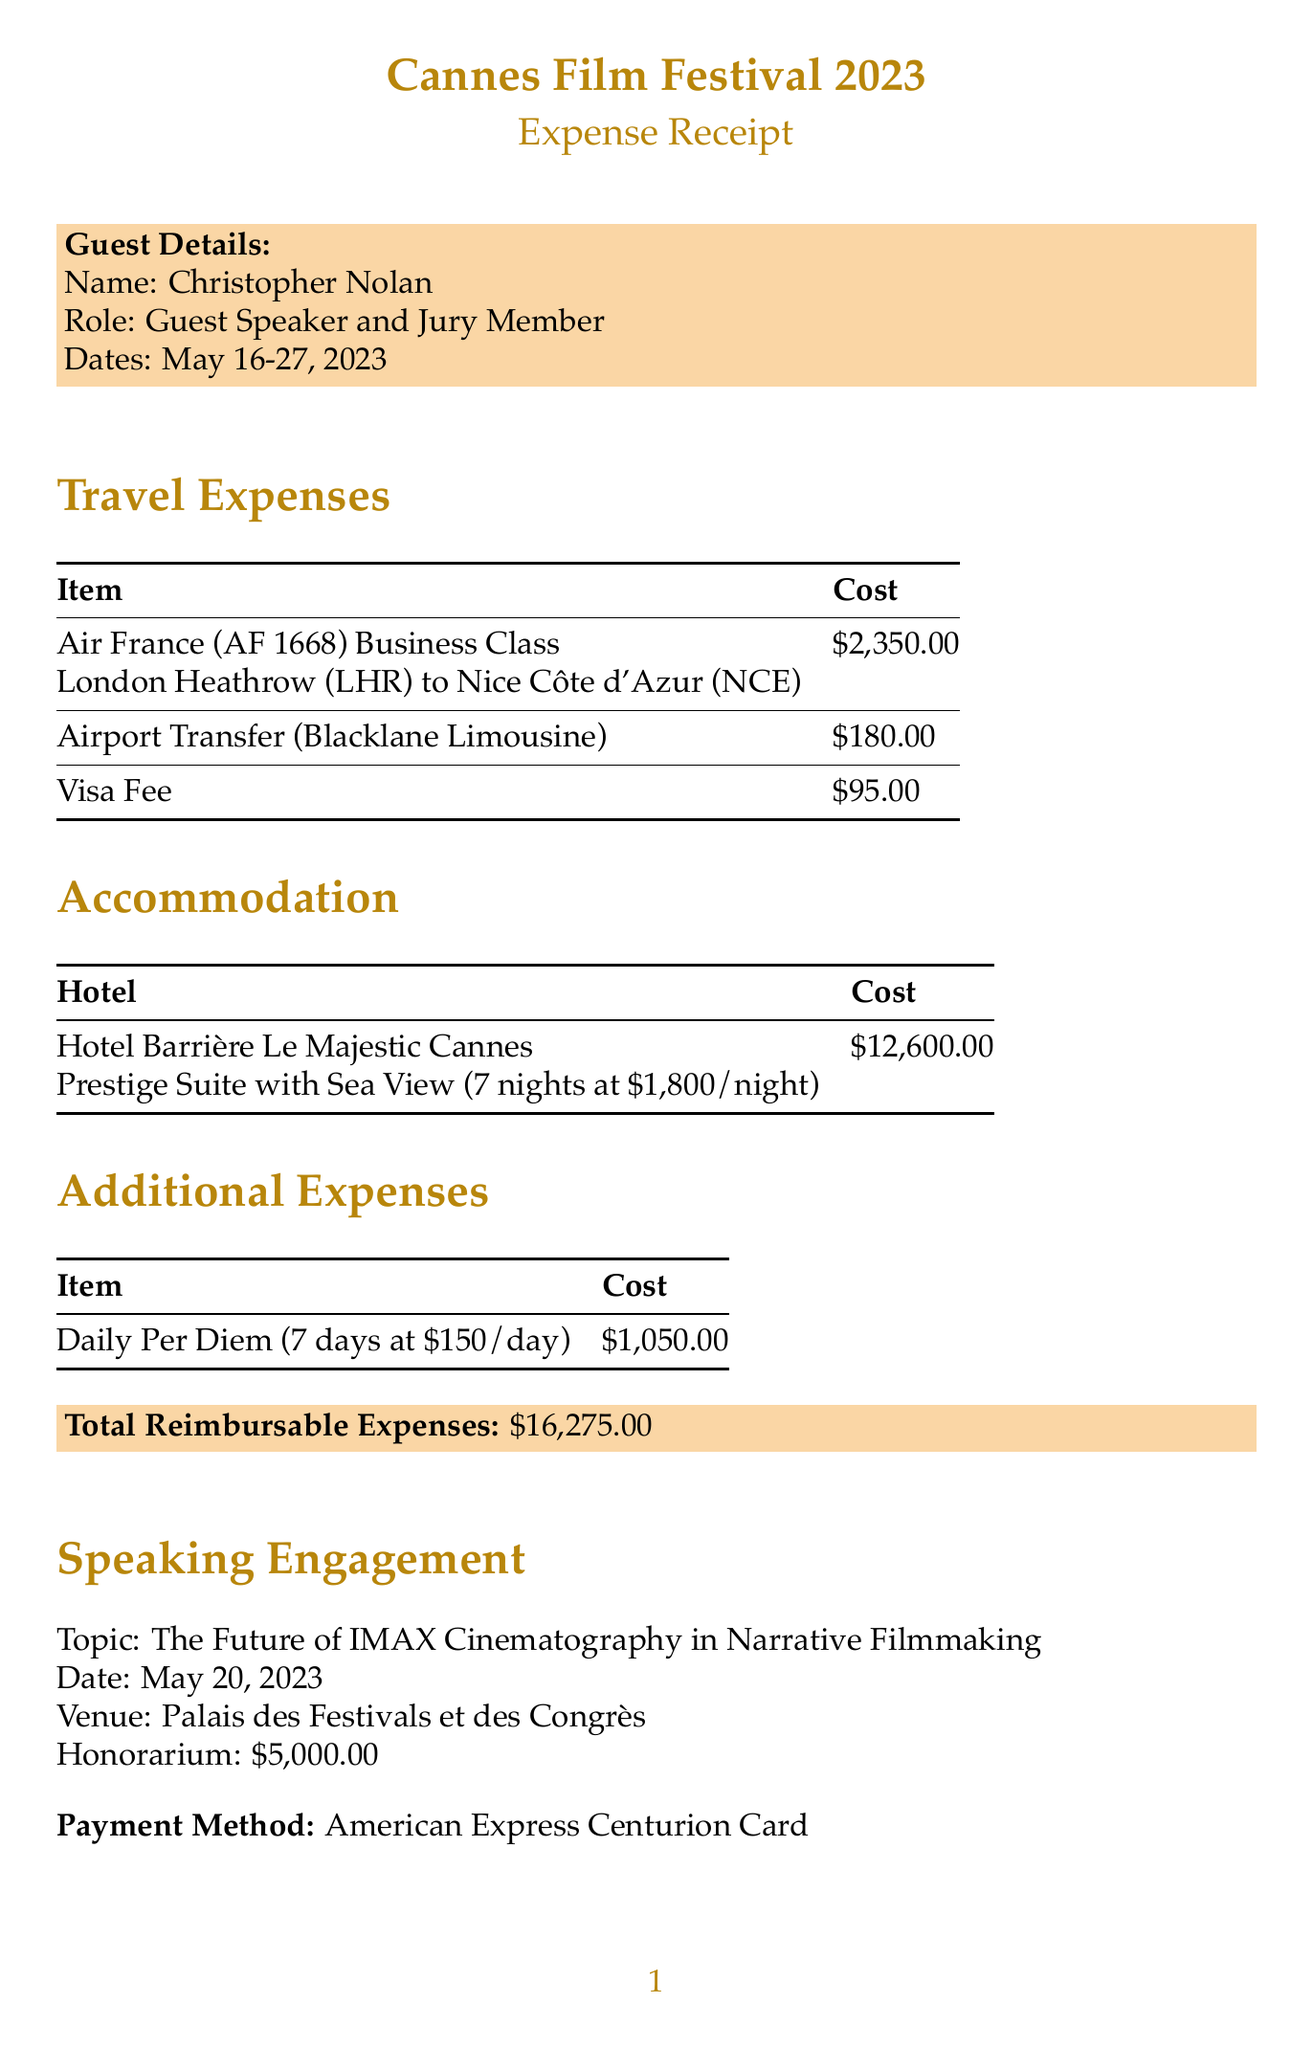What is the guest's name? The guest's name is provided in the document under the guest details section.
Answer: Christopher Nolan What is the total cost of accommodation? The total accommodation cost is clearly stated in the accommodation section of the document.
Answer: 12600.00 What is the departure airport? The departure airport is mentioned in the travel expenses section.
Answer: London Heathrow (LHR) How many nights did the guest stay? The number of nights stayed is specified in the accommodation section.
Answer: 7 What is the honorarium for the speaking engagement? The honorarium amount is stated in the speaking engagement section of the document.
Answer: 5000.00 What airline did the guest fly with? The airline is indicated in the travel expenses section with the flight details.
Answer: Air France What is the total reimbursable expenses? The total reimbursable expenses can be found in the summary of expenses at the end of the document.
Answer: 16275.00 What is the daily per diem amount? The daily per diem amount is mentioned in the additional expenses section.
Answer: 150.00 Who is the reimbursement contact? The reimbursement contact is specified in the reimbursement contact section.
Answer: Sarah Johnson 